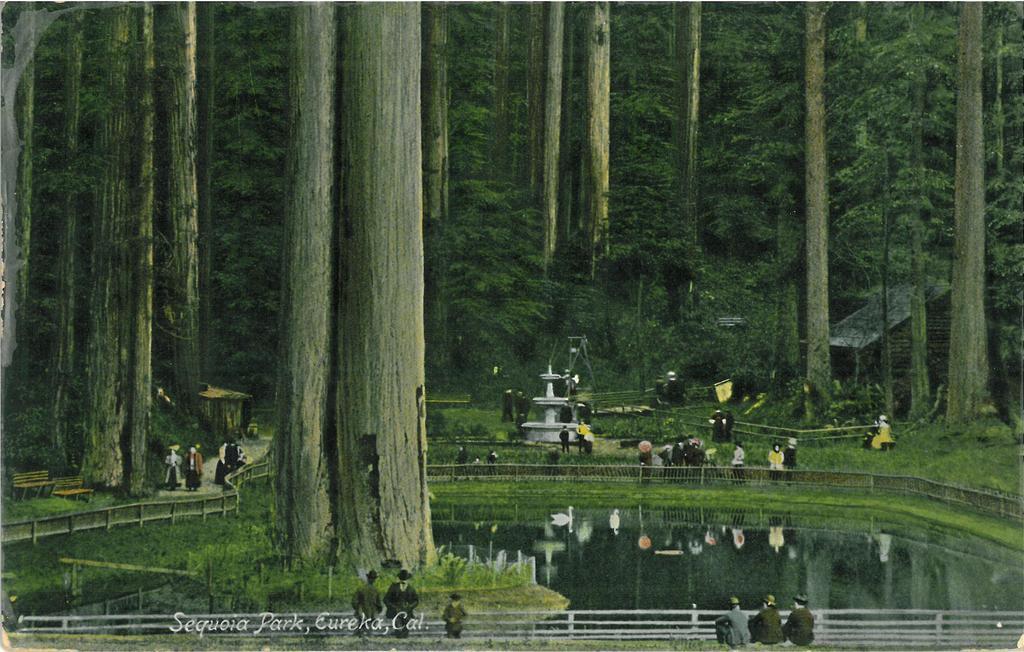Describe this image in one or two sentences. In this image I can see the white colored railing, few persons sitting and few persons standing, the water and few birds which are white in color on the surface of the water. I can see the white colored fountain, few benches, a house and few trees. 